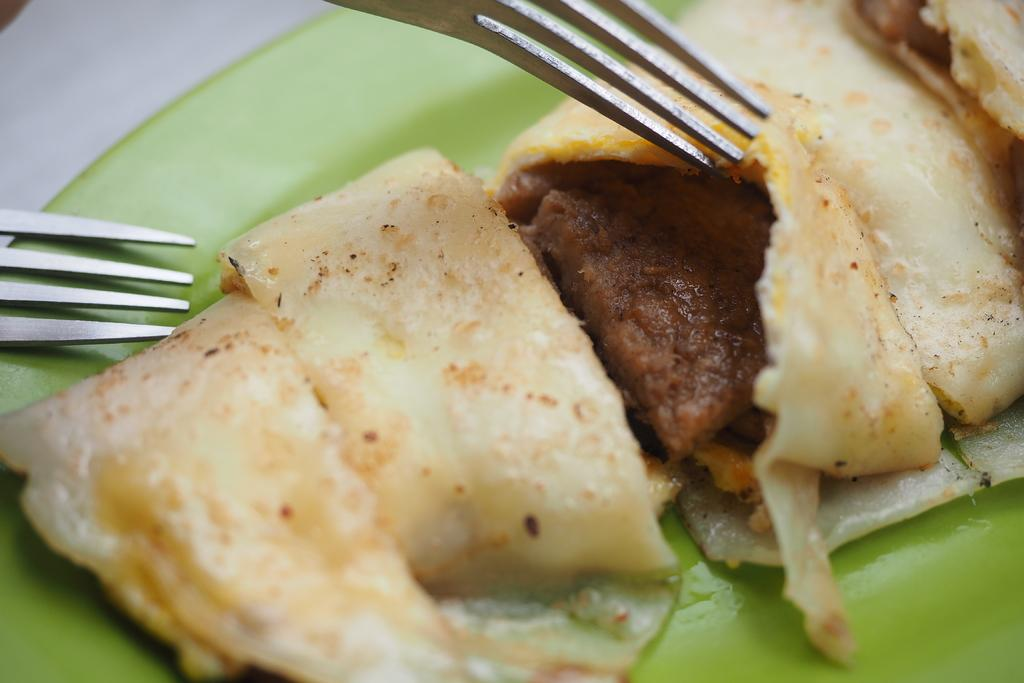What is present on the plate in the image? There is food on the plate in the image. How many forks are visible in the image? There are two forks in the image. What type of border is present around the food on the plate? There is no mention of a border around the food on the plate in the provided facts. 